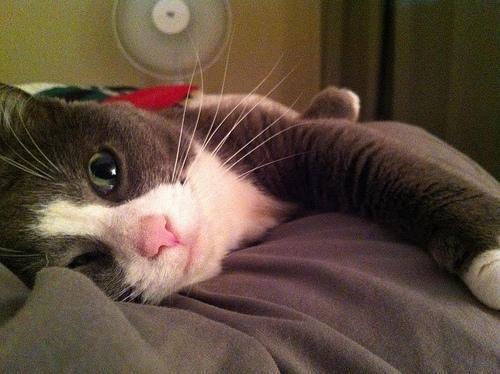How many cats are there?
Give a very brief answer. 1. 